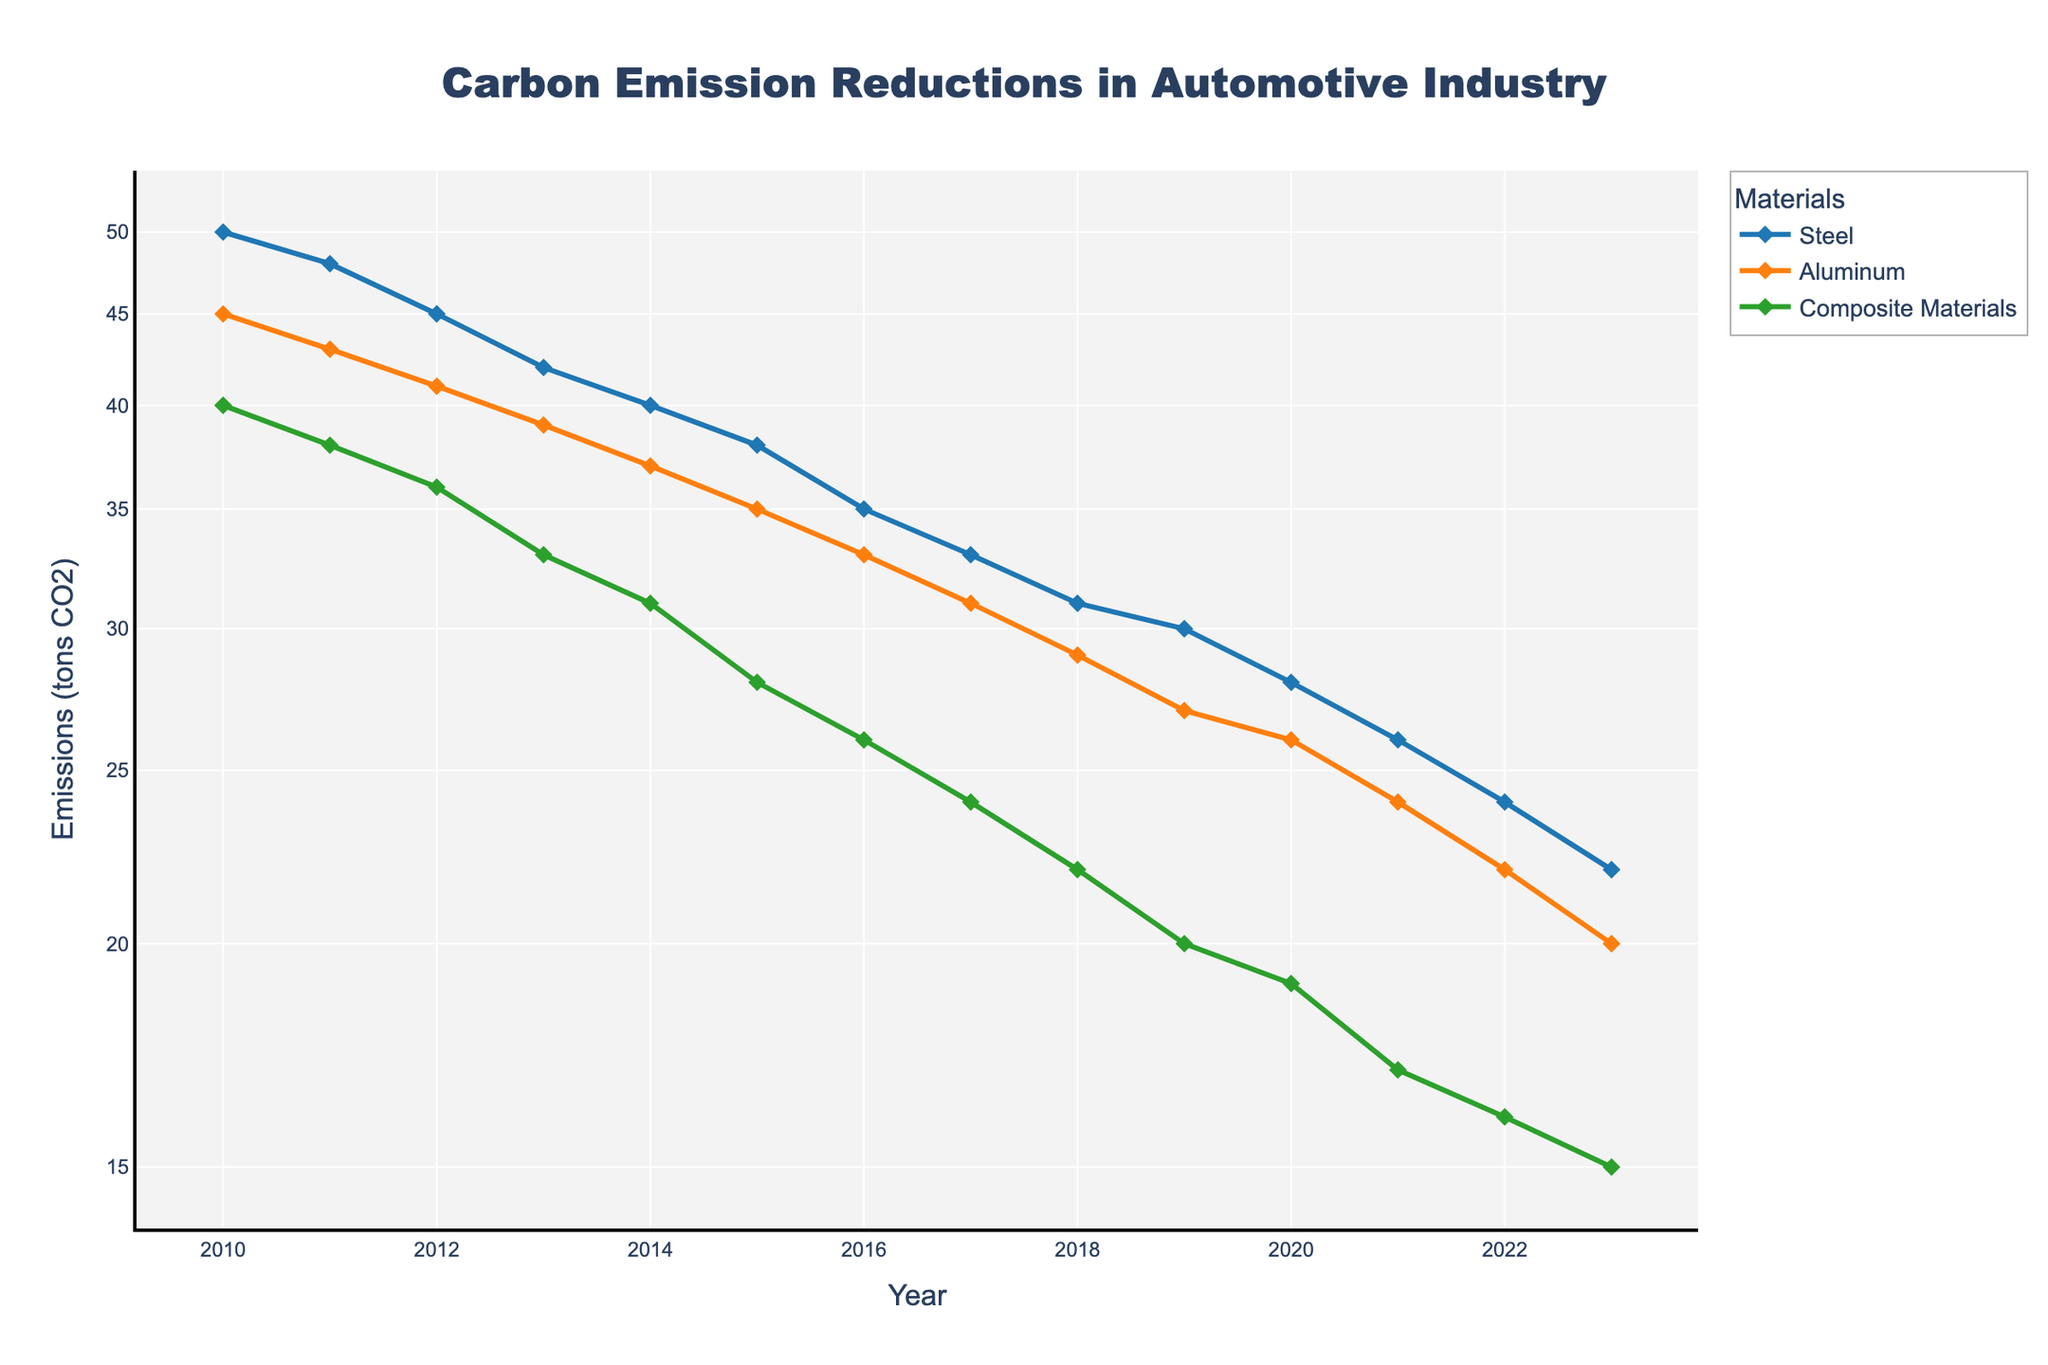What is the title of the figure? The title of the figure is displayed at the top of the plot and reads "Carbon Emission Reductions in Automotive Industry".
Answer: Carbon Emission Reductions in Automotive Industry What are the three materials compared in the plot? The plot shows three materials labeled in the legend: Steel, Aluminum, and Composite Materials.
Answer: Steel, Aluminum, Composite Materials How do the carbon emissions from steel change from 2010 to 2023? Looking at the line representing steel emissions, it starts from 50 tons CO2 in 2010 and decreases to 22 tons CO2 by 2023.
Answer: 50 tons CO2 to 22 tons CO2 In which year do composite materials have the lowest carbon emissions, and what is that value? The lowest point on the Composite Materials line occurs in 2023, and its value is 15 tons CO2.
Answer: 2023, 15 tons CO2 Which material shows a consistent decrease in carbon emissions every year from 2010 to 2023? By following each line, all three materials (Steel, Aluminum, Composite Materials) show consistent decreases in carbon emissions every year.
Answer: Steel, Aluminum, Composite Materials By what percentage did carbon emissions from aluminum reduce from 2016 to 2017? In 2016, aluminum emissions were 33 tons CO2, and in 2017, they were 31 tons CO2. The percentage reduction is ((33-31)/33)*100 = 6.06%.
Answer: 6.06% What is the difference in carbon emissions between aluminum and steel in 2020? From the y-axis values, steel emissions in 2020 are 28 tons CO2 and aluminum emissions are 26 tons CO2. The difference is 28 - 26 = 2 tons CO2.
Answer: 2 tons CO2 Which material has the steepest decline in emissions at any point, and during which years does this occur? The steepest decline appears in composite materials between 2017 (24 tons CO2) and 2018 (22 tons CO2), showing a significant reduction in one year.
Answer: Composite Materials, 2017 to 2018 What is the average carbon emission from composite materials from 2010 to 2023? Summing emissions from 2010 to 2023 for composite materials (40, 38, 36, 33, 31, 28, 26, 24, 22, 20, 19, 17, 16, 15) and averaging: (40+38+36+33+31+28+26+24+22+20+19+17+16+15)/14 ≈ 26.5 tons CO2.
Answer: 26.5 tons CO2 What trend can be observed about carbon emissions of all materials during the period of 2010 to 2023? All three materials show a downward trend in carbon emissions over the years from 2010 to 2023, indicating improvements in reducing emissions each year.
Answer: Downward trend 